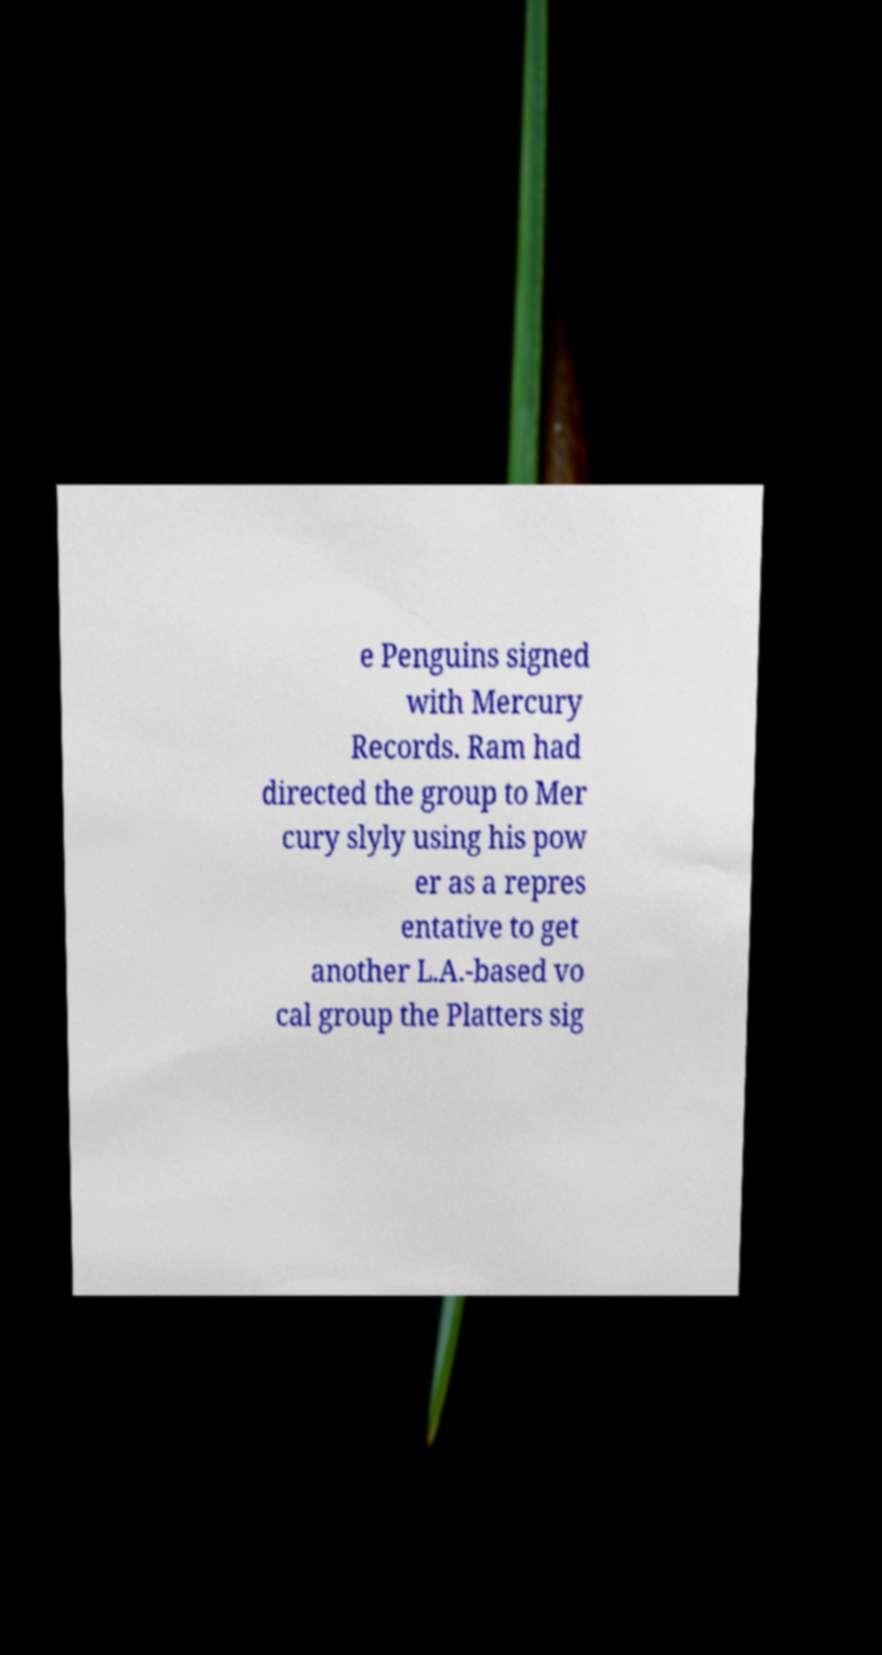What messages or text are displayed in this image? I need them in a readable, typed format. e Penguins signed with Mercury Records. Ram had directed the group to Mer cury slyly using his pow er as a repres entative to get another L.A.-based vo cal group the Platters sig 